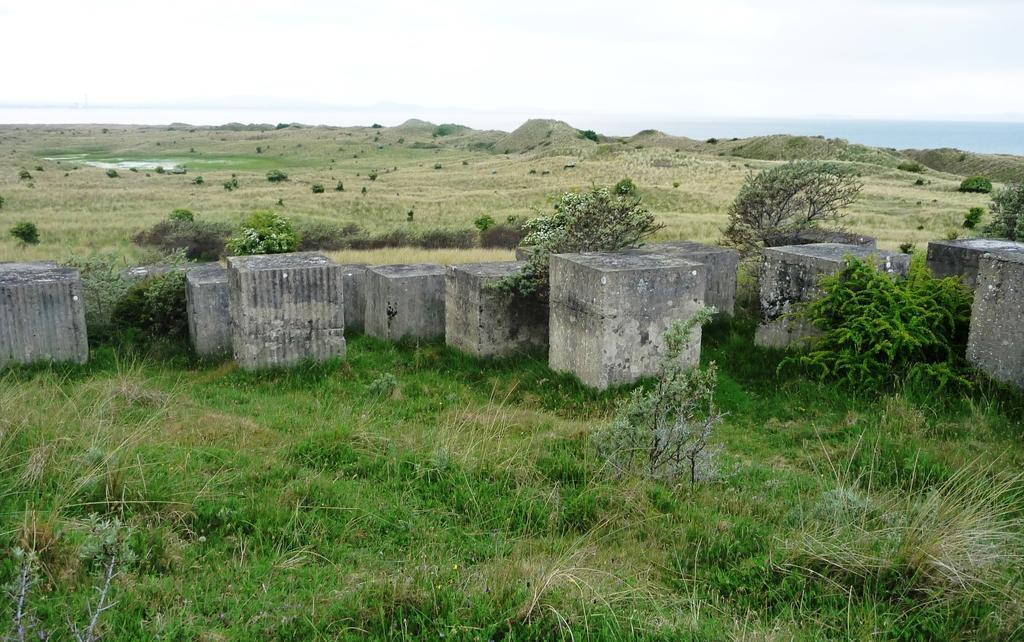How would you summarize this image in a sentence or two? In this picture i can see there is grass, plants and pillars and the sky is clear. 